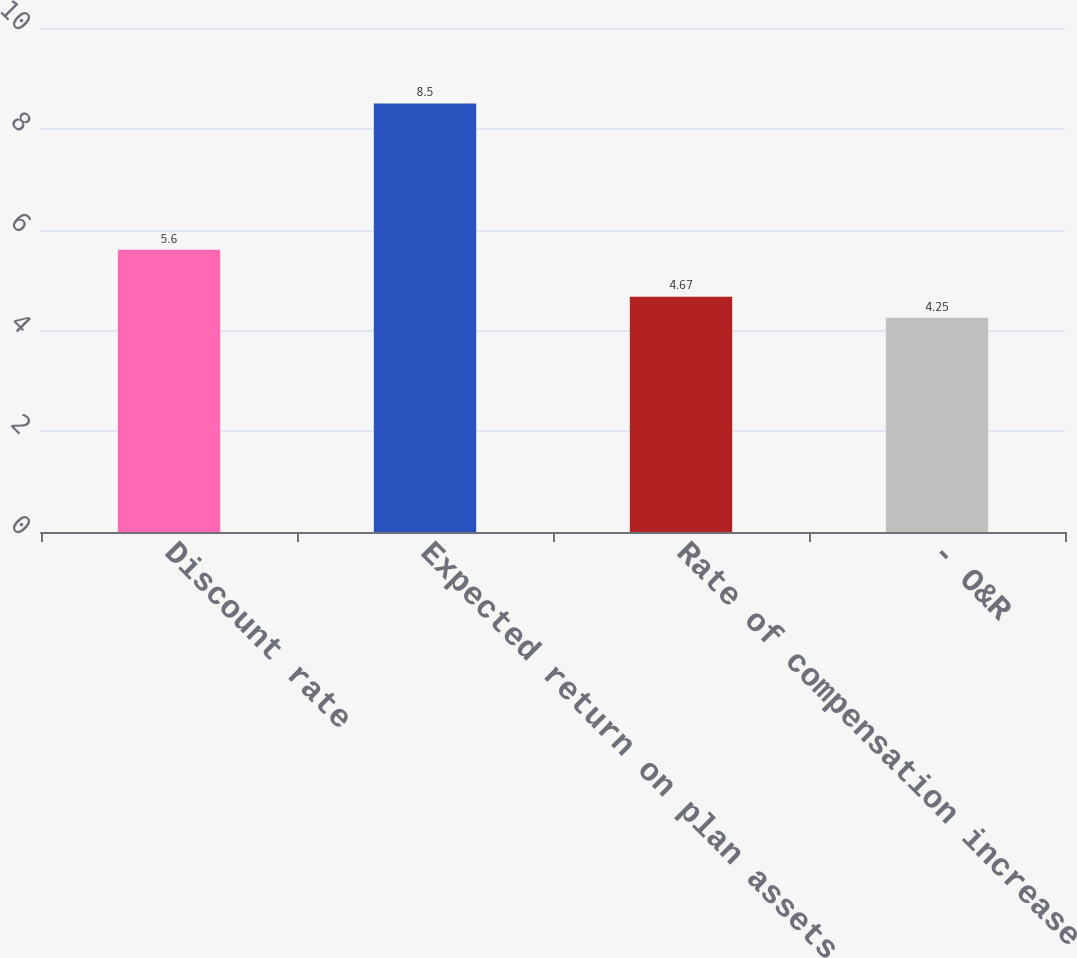Convert chart. <chart><loc_0><loc_0><loc_500><loc_500><bar_chart><fcel>Discount rate<fcel>Expected return on plan assets<fcel>Rate of compensation increase<fcel>- O&R<nl><fcel>5.6<fcel>8.5<fcel>4.67<fcel>4.25<nl></chart> 